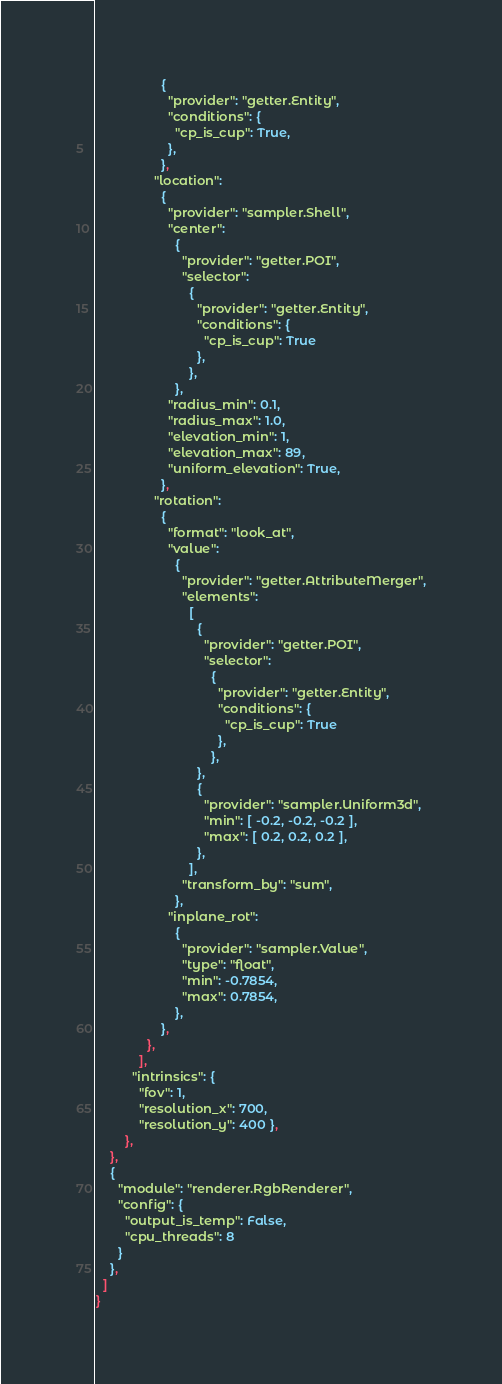Convert code to text. <code><loc_0><loc_0><loc_500><loc_500><_YAML_>                  {
                    "provider": "getter.Entity",
                    "conditions": {
                      "cp_is_cup": True,
                    },
                  },
                "location":
                  {
                    "provider": "sampler.Shell",
                    "center":
                      {
                        "provider": "getter.POI",
                        "selector":
                          {
                            "provider": "getter.Entity",
                            "conditions": {
                              "cp_is_cup": True
                            },
                          },
                      },
                    "radius_min": 0.1,
                    "radius_max": 1.0,
                    "elevation_min": 1,
                    "elevation_max": 89,
                    "uniform_elevation": True,
                  },
                "rotation":
                  {
                    "format": "look_at",
                    "value":
                      {
                        "provider": "getter.AttributeMerger",
                        "elements":
                          [
                            {
                              "provider": "getter.POI",
                              "selector":
                                {
                                  "provider": "getter.Entity",
                                  "conditions": {
                                    "cp_is_cup": True
                                  },
                                },
                            },
                            {
                              "provider": "sampler.Uniform3d",
                              "min": [ -0.2, -0.2, -0.2 ],
                              "max": [ 0.2, 0.2, 0.2 ],
                            },
                          ],
                        "transform_by": "sum",
                      },
                    "inplane_rot":
                      {
                        "provider": "sampler.Value",
                        "type": "float",
                        "min": -0.7854,
                        "max": 0.7854,
                      },
                  },
              },
            ],
          "intrinsics": {
            "fov": 1,
            "resolution_x": 700,
            "resolution_y": 400 },
        },
    },
    {
      "module": "renderer.RgbRenderer",
      "config": {
        "output_is_temp": False,
        "cpu_threads": 8
      }
    },
  ]
}
</code> 